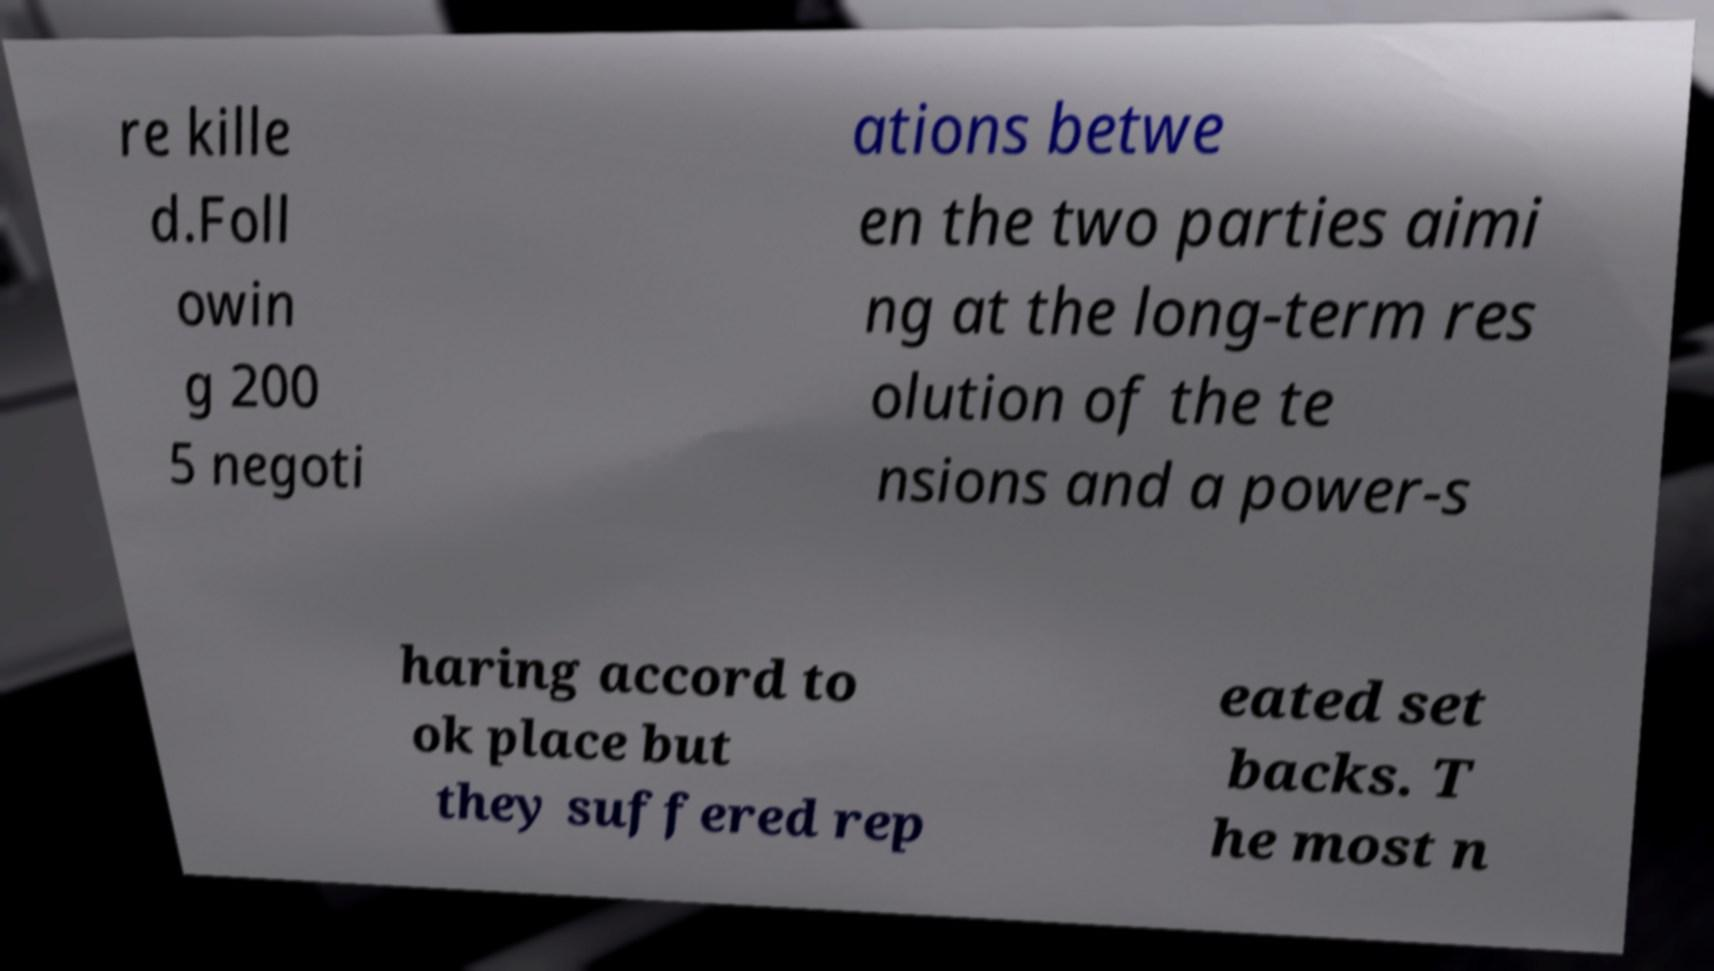There's text embedded in this image that I need extracted. Can you transcribe it verbatim? re kille d.Foll owin g 200 5 negoti ations betwe en the two parties aimi ng at the long-term res olution of the te nsions and a power-s haring accord to ok place but they suffered rep eated set backs. T he most n 